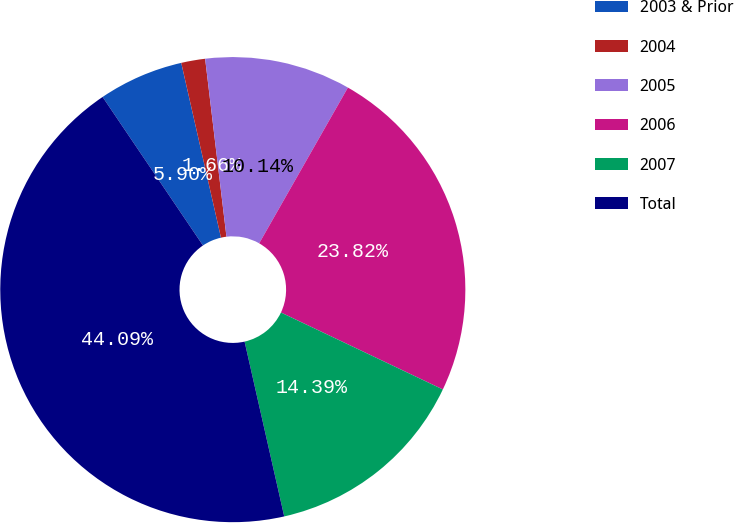Convert chart. <chart><loc_0><loc_0><loc_500><loc_500><pie_chart><fcel>2003 & Prior<fcel>2004<fcel>2005<fcel>2006<fcel>2007<fcel>Total<nl><fcel>5.9%<fcel>1.66%<fcel>10.14%<fcel>23.82%<fcel>14.39%<fcel>44.09%<nl></chart> 